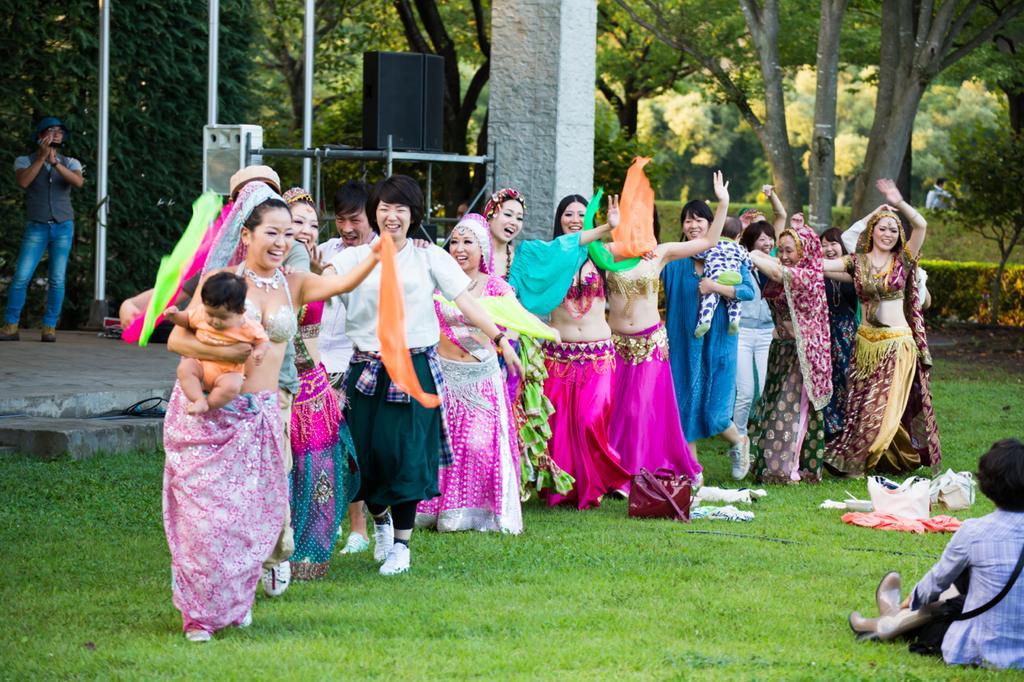Please provide a concise description of this image. In this image I can see the group of people with different color dresses. These people are standing on the ground. To the right I can see one person sitting. In the background I can see the sound box, pillar and many trees. 